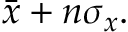<formula> <loc_0><loc_0><loc_500><loc_500>\bar { x } + n \sigma _ { x } .</formula> 